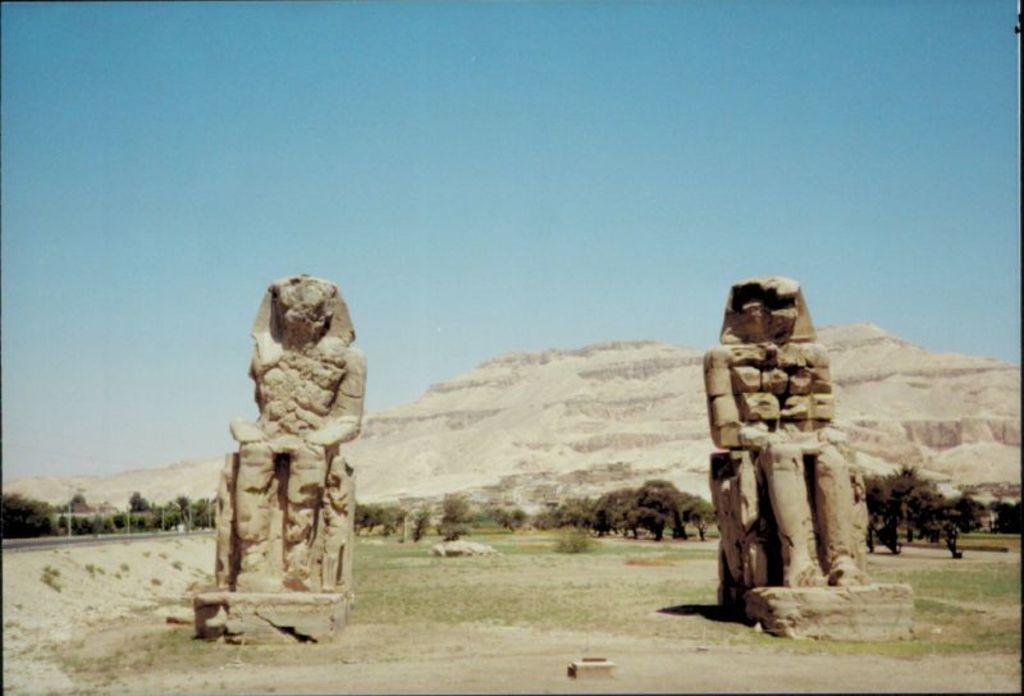How many statues can be seen in the image? There are 2 statues in the image. What is visible beneath the statues? The ground is visible in the image. What can be seen in the distance behind the statues? There are trees, mountains, and a clear sky in the background of the image. What type of feeling does the yard have in the image? There is no yard present in the image, so it is not possible to determine the feeling of a yard. 